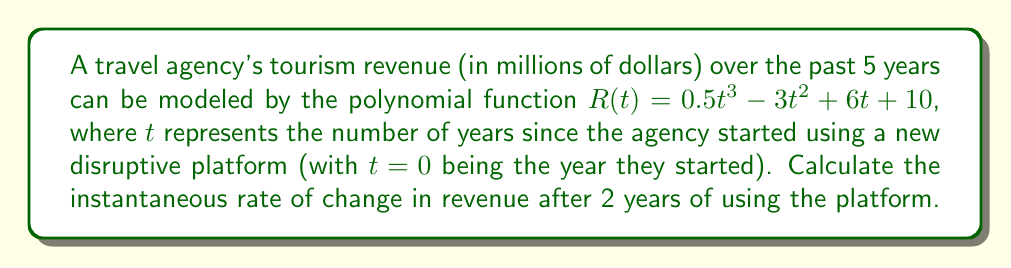Provide a solution to this math problem. To find the instantaneous rate of change in revenue after 2 years, we need to calculate the derivative of the revenue function $R(t)$ and evaluate it at $t=2$. Here's the step-by-step process:

1) The revenue function is given as:
   $R(t) = 0.5t^3 - 3t^2 + 6t + 10$

2) To find the derivative, we apply the power rule to each term:
   $R'(t) = 1.5t^2 - 6t + 6$

3) This derivative function $R'(t)$ represents the instantaneous rate of change of revenue at any time $t$.

4) To find the rate of change after 2 years, we evaluate $R'(2)$:
   $R'(2) = 1.5(2)^2 - 6(2) + 6$
   $= 1.5(4) - 12 + 6$
   $= 6 - 12 + 6$
   $= 0$

5) Therefore, the instantaneous rate of change in revenue after 2 years of using the platform is 0 million dollars per year.
Answer: $0$ million dollars per year 